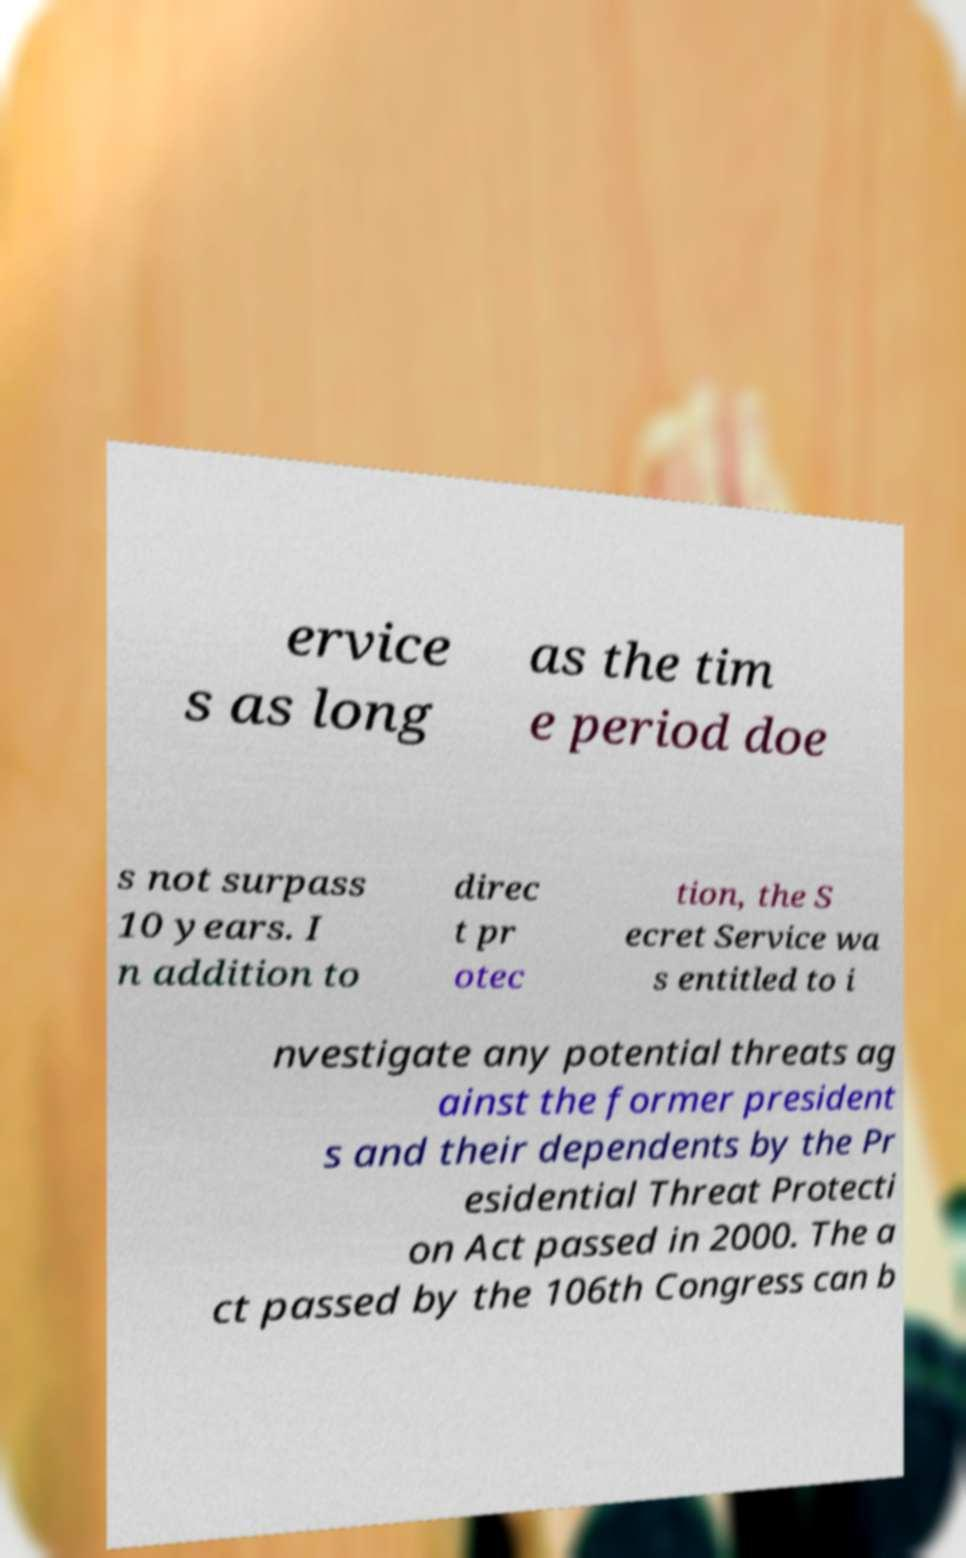What messages or text are displayed in this image? I need them in a readable, typed format. ervice s as long as the tim e period doe s not surpass 10 years. I n addition to direc t pr otec tion, the S ecret Service wa s entitled to i nvestigate any potential threats ag ainst the former president s and their dependents by the Pr esidential Threat Protecti on Act passed in 2000. The a ct passed by the 106th Congress can b 